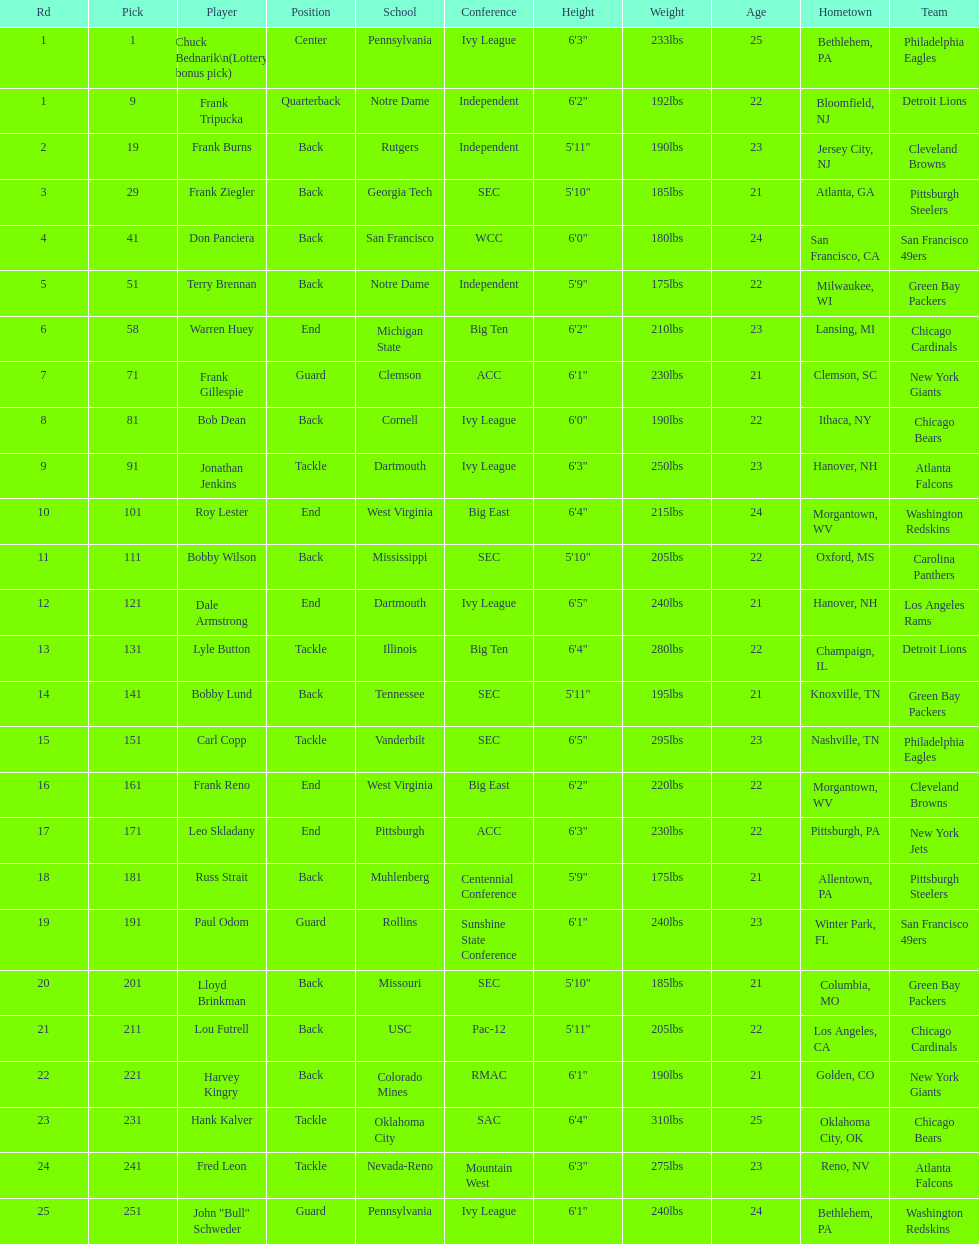What's the maximum rd value? 25. 